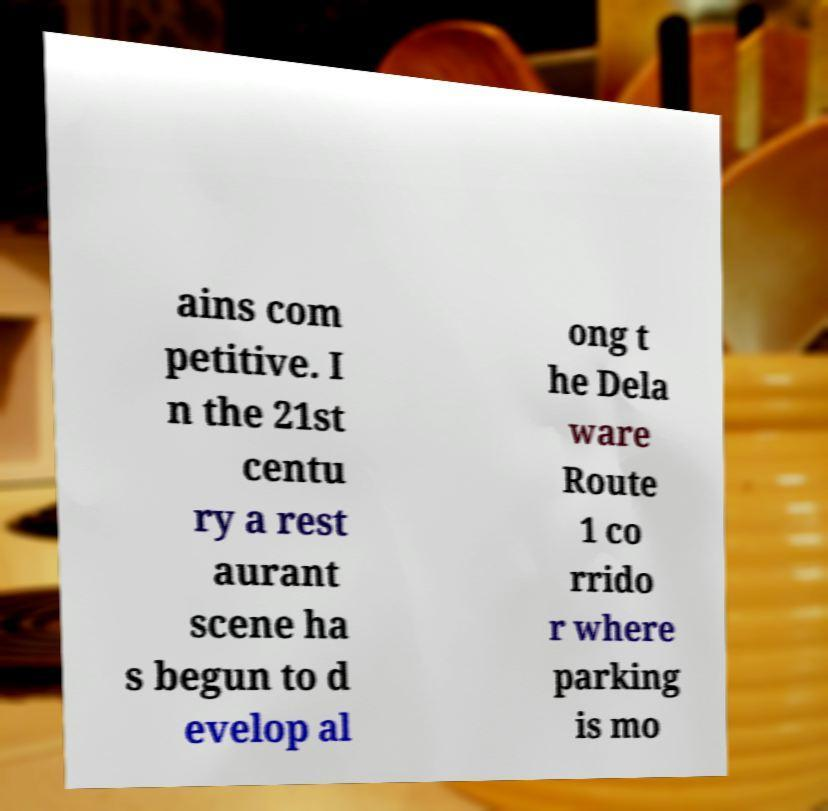There's text embedded in this image that I need extracted. Can you transcribe it verbatim? ains com petitive. I n the 21st centu ry a rest aurant scene ha s begun to d evelop al ong t he Dela ware Route 1 co rrido r where parking is mo 